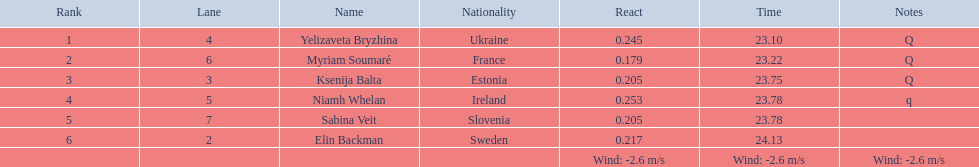What are all the names? Yelizaveta Bryzhina, Myriam Soumaré, Ksenija Balta, Niamh Whelan, Sabina Veit, Elin Backman. What were their finishing times? 23.10, 23.22, 23.75, 23.78, 23.78, 24.13. And which time was reached by ellen backman? 24.13. 